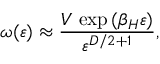Convert formula to latex. <formula><loc_0><loc_0><loc_500><loc_500>\omega ( \varepsilon ) \approx { \frac { V \, \exp { ( \beta _ { H } \varepsilon ) } } { \varepsilon ^ { D / 2 + 1 } } } ,</formula> 